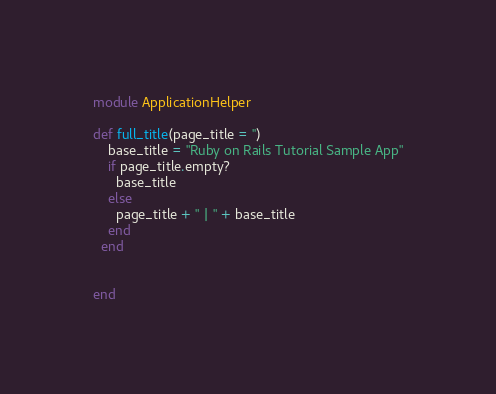<code> <loc_0><loc_0><loc_500><loc_500><_Ruby_>module ApplicationHelper

def full_title(page_title = '')
    base_title = "Ruby on Rails Tutorial Sample App"
    if page_title.empty?
      base_title
    else
      page_title + " | " + base_title
    end
  end


end
</code> 